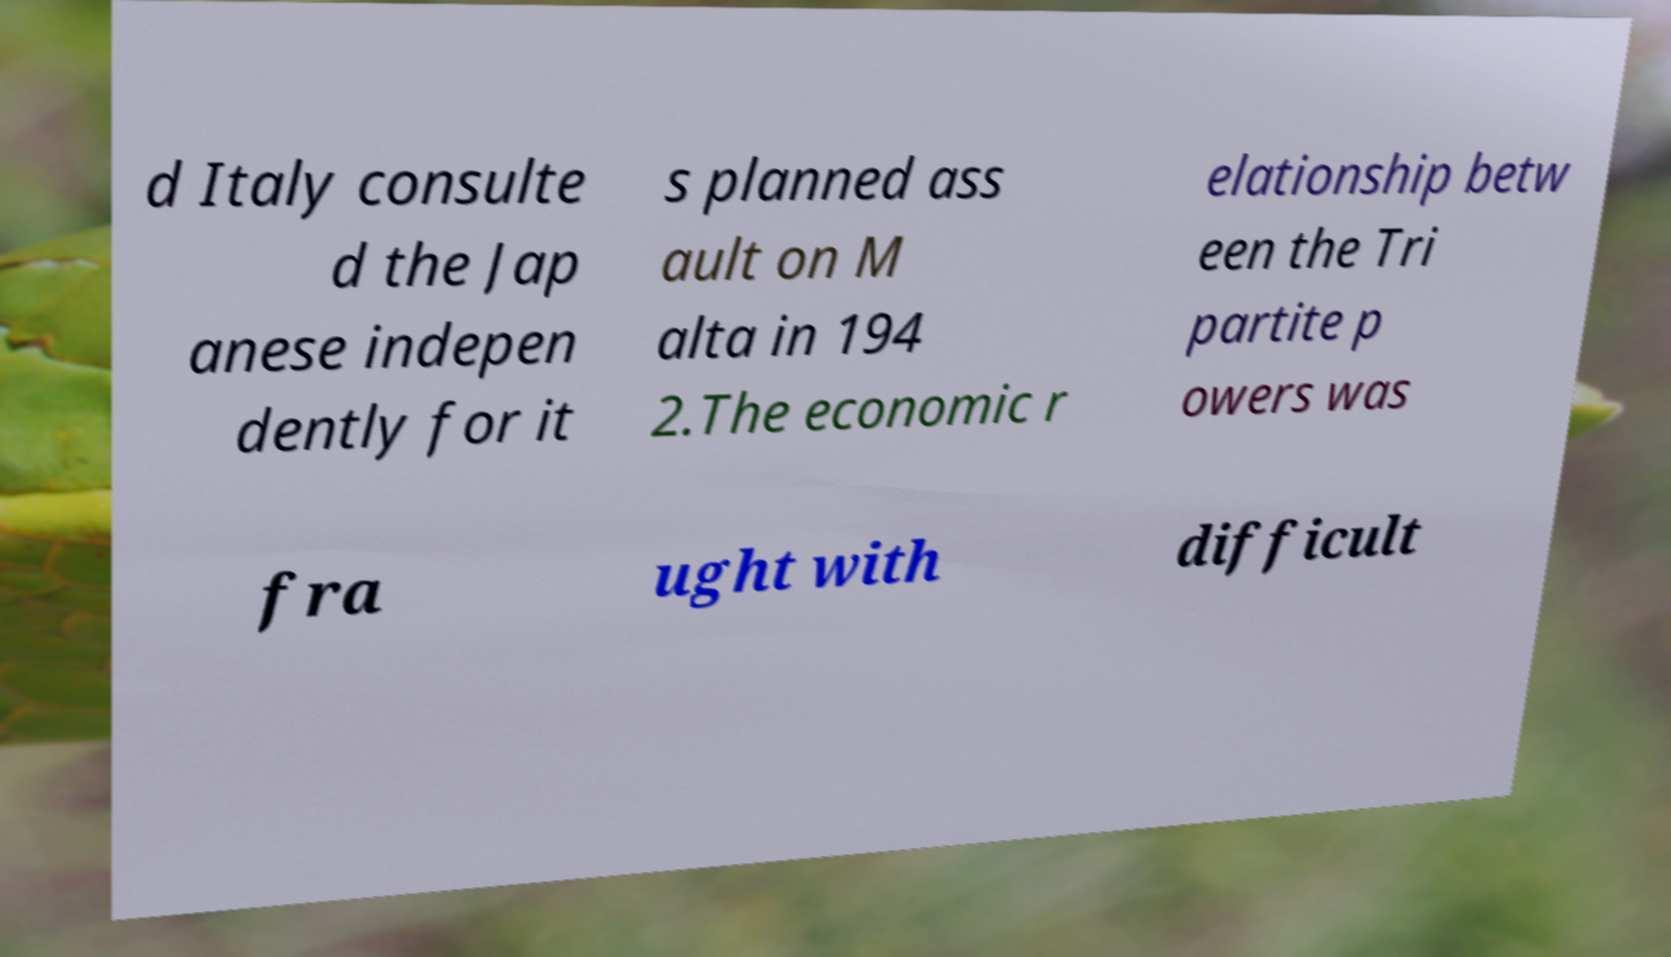There's text embedded in this image that I need extracted. Can you transcribe it verbatim? d Italy consulte d the Jap anese indepen dently for it s planned ass ault on M alta in 194 2.The economic r elationship betw een the Tri partite p owers was fra ught with difficult 